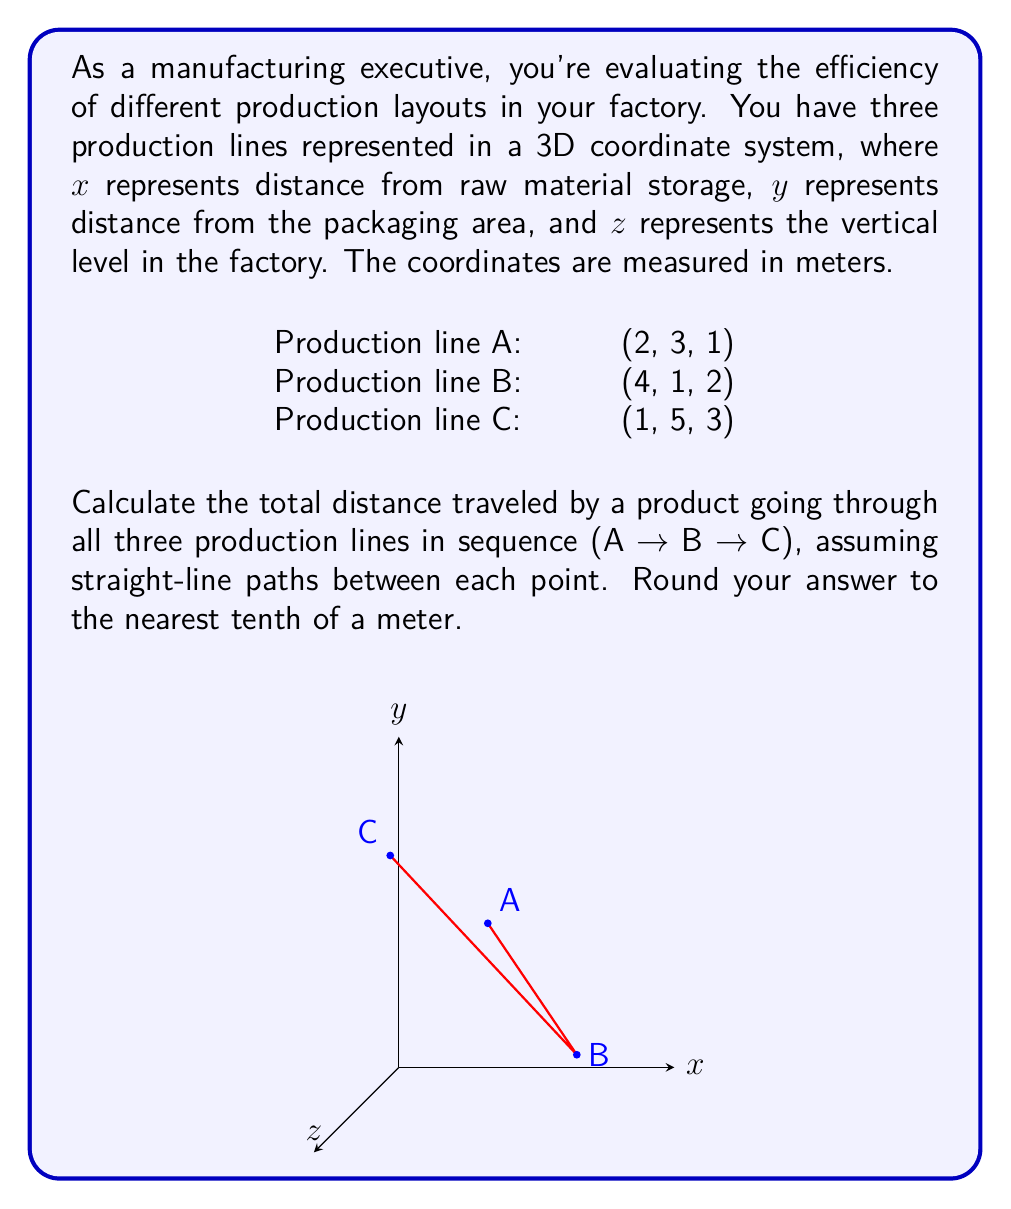Show me your answer to this math problem. To solve this problem, we need to calculate the distance between each pair of points and sum them up. We can use the 3D distance formula:

$$d = \sqrt{(x_2-x_1)^2 + (y_2-y_1)^2 + (z_2-z_1)^2}$$

Step 1: Calculate distance from A to B
$$d_{AB} = \sqrt{(4-2)^2 + (1-3)^2 + (2-1)^2}$$
$$d_{AB} = \sqrt{2^2 + (-2)^2 + 1^2} = \sqrt{4 + 4 + 1} = \sqrt{9} = 3$$

Step 2: Calculate distance from B to C
$$d_{BC} = \sqrt{(1-4)^2 + (5-1)^2 + (3-2)^2}$$
$$d_{BC} = \sqrt{(-3)^2 + 4^2 + 1^2} = \sqrt{9 + 16 + 1} = \sqrt{26} \approx 5.1$$

Step 3: Sum up the distances
Total distance = $d_{AB} + d_{BC} = 3 + 5.1 = 8.1$ meters

Step 4: Round to the nearest tenth
8.1 meters (already rounded)
Answer: 8.1 meters 